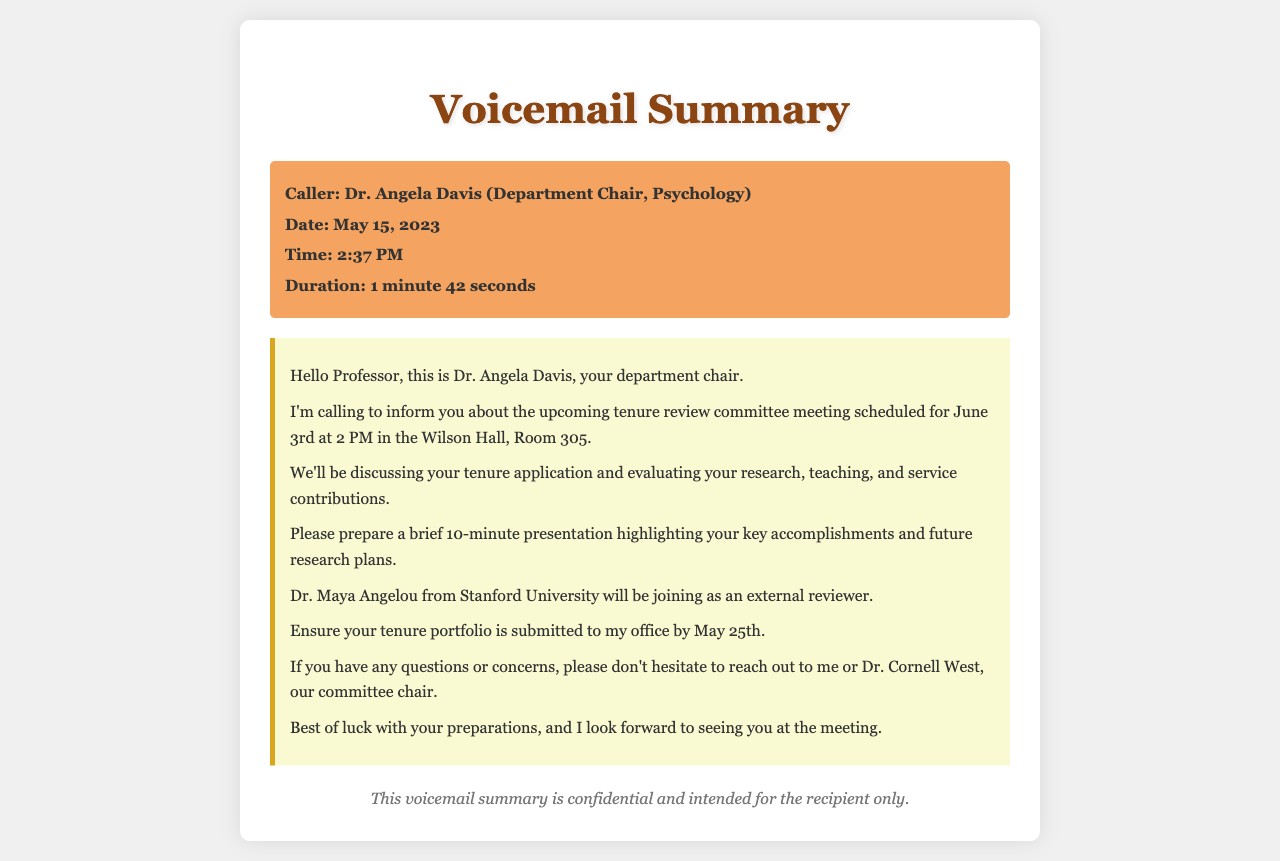What is the date of the tenure review committee meeting? The document states that the tenure review committee meeting is scheduled for June 3rd.
Answer: June 3rd Who is the caller? The caller, as mentioned in the document, is Dr. Angela Davis, the Department Chair of Psychology.
Answer: Dr. Angela Davis What time is the meeting set to start? The voicemail summary specifies that the meeting is scheduled for 2 PM.
Answer: 2 PM When should the tenure portfolio be submitted? According to the voicemail, the tenure portfolio must be submitted by May 25th.
Answer: May 25th How long is the presentation expected to be? The document indicates that the presentation should be a brief 10 minutes.
Answer: 10 minutes Who will be joining as an external reviewer? The voicemail mentions that Dr. Maya Angelou from Stanford University will be the external reviewer.
Answer: Dr. Maya Angelou What contributions will the committee evaluate? The voicemail specifies that the committee will evaluate research, teaching, and service contributions.
Answer: Research, teaching, and service Who should be contacted for questions or concerns? The document advises to reach out to Dr. Angela Davis or Dr. Cornell West for any questions or concerns.
Answer: Dr. Angela Davis or Dr. Cornell West What is the duration of the call? The voicemail summary states the call duration was 1 minute and 42 seconds.
Answer: 1 minute 42 seconds 